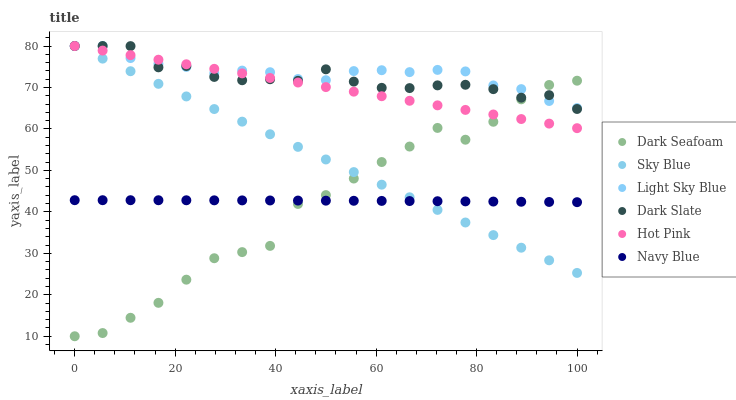Does Dark Seafoam have the minimum area under the curve?
Answer yes or no. Yes. Does Light Sky Blue have the maximum area under the curve?
Answer yes or no. Yes. Does Hot Pink have the minimum area under the curve?
Answer yes or no. No. Does Hot Pink have the maximum area under the curve?
Answer yes or no. No. Is Sky Blue the smoothest?
Answer yes or no. Yes. Is Dark Seafoam the roughest?
Answer yes or no. Yes. Is Hot Pink the smoothest?
Answer yes or no. No. Is Hot Pink the roughest?
Answer yes or no. No. Does Dark Seafoam have the lowest value?
Answer yes or no. Yes. Does Hot Pink have the lowest value?
Answer yes or no. No. Does Sky Blue have the highest value?
Answer yes or no. Yes. Does Dark Seafoam have the highest value?
Answer yes or no. No. Is Navy Blue less than Light Sky Blue?
Answer yes or no. Yes. Is Dark Slate greater than Navy Blue?
Answer yes or no. Yes. Does Dark Seafoam intersect Hot Pink?
Answer yes or no. Yes. Is Dark Seafoam less than Hot Pink?
Answer yes or no. No. Is Dark Seafoam greater than Hot Pink?
Answer yes or no. No. Does Navy Blue intersect Light Sky Blue?
Answer yes or no. No. 